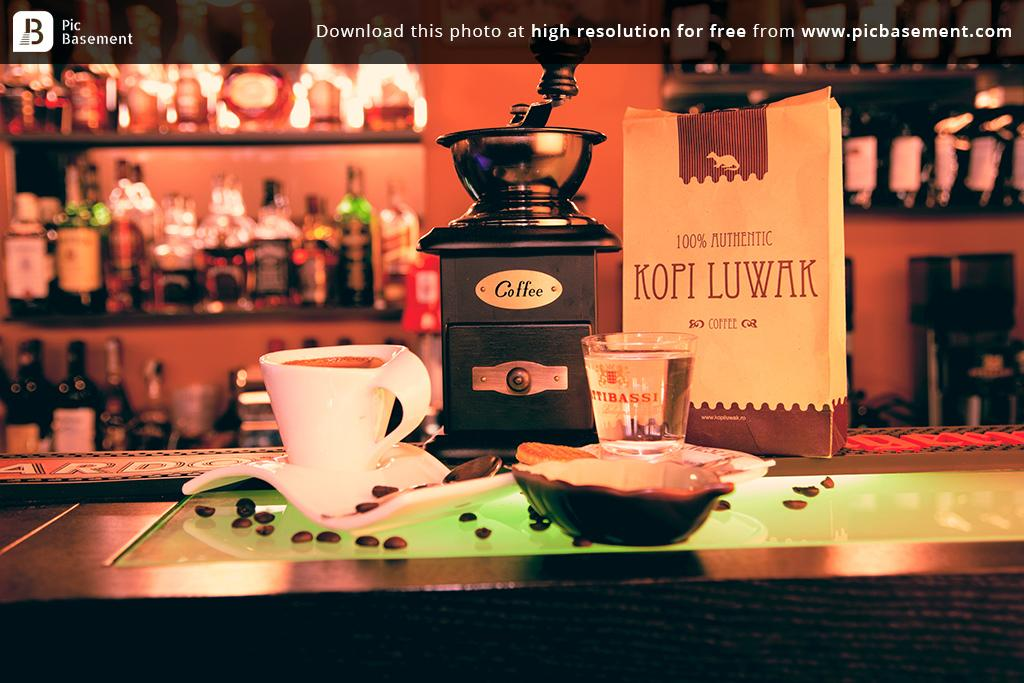<image>
Describe the image concisely. A mug of coffee on a bar next to a Kopi Luwark brown and tan bag with a coffee grinder to the side. 